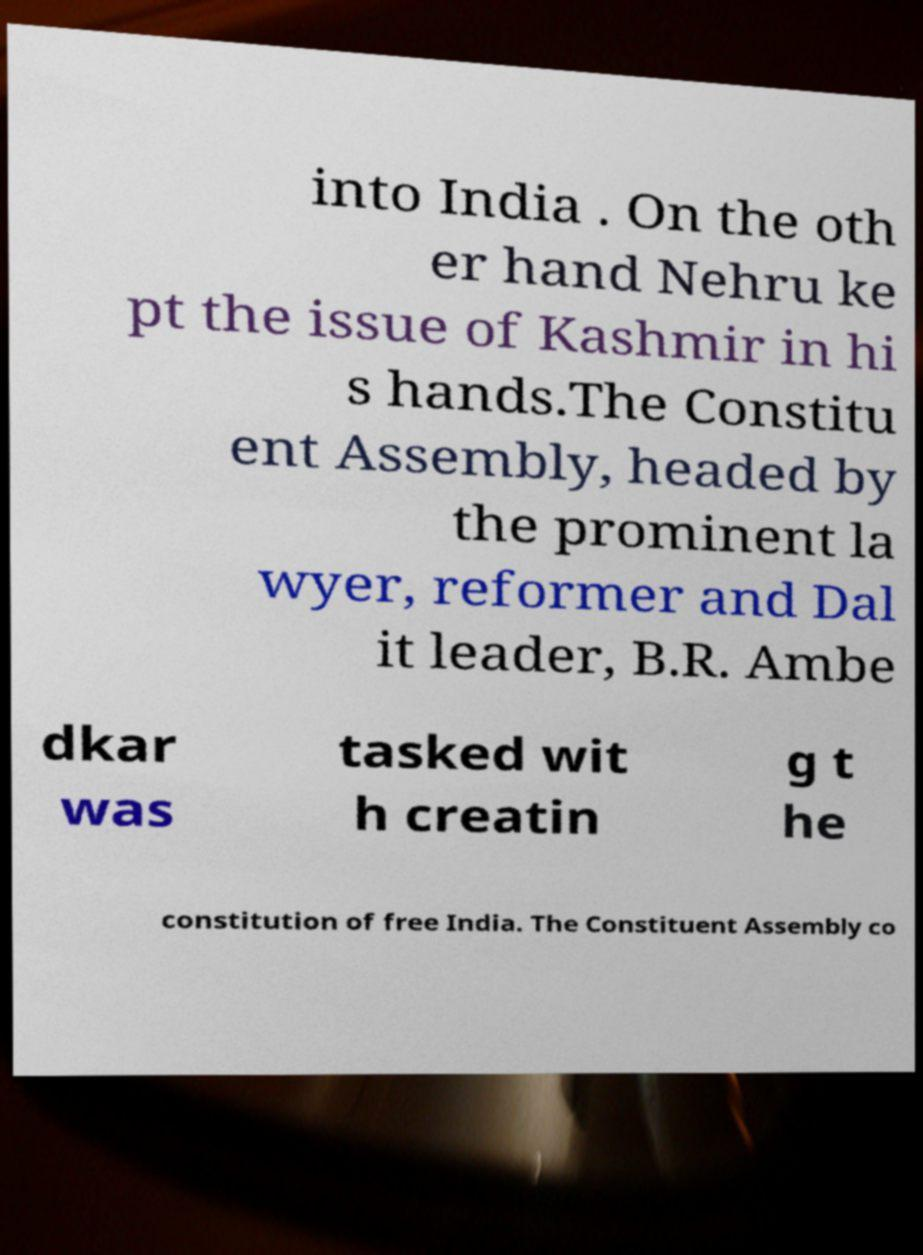I need the written content from this picture converted into text. Can you do that? into India . On the oth er hand Nehru ke pt the issue of Kashmir in hi s hands.The Constitu ent Assembly, headed by the prominent la wyer, reformer and Dal it leader, B.R. Ambe dkar was tasked wit h creatin g t he constitution of free India. The Constituent Assembly co 